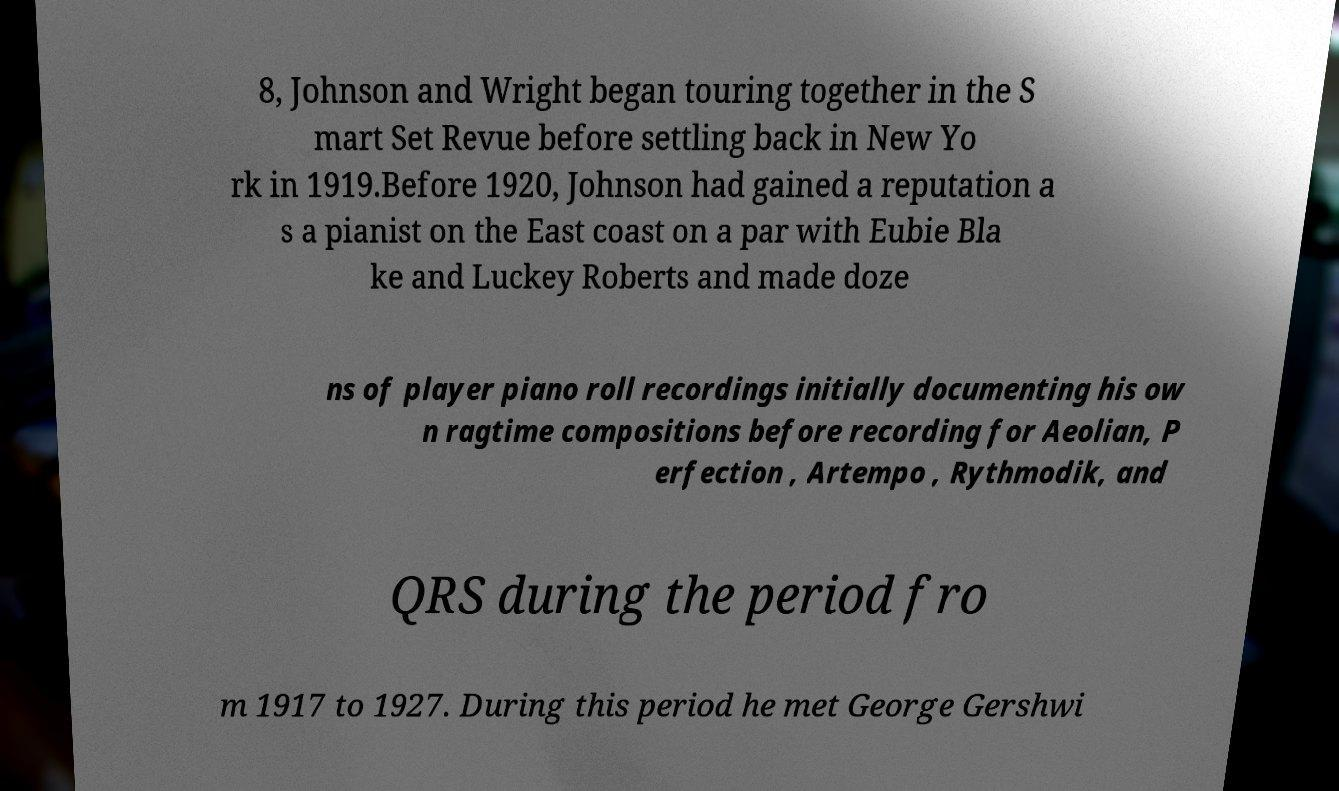Could you assist in decoding the text presented in this image and type it out clearly? 8, Johnson and Wright began touring together in the S mart Set Revue before settling back in New Yo rk in 1919.Before 1920, Johnson had gained a reputation a s a pianist on the East coast on a par with Eubie Bla ke and Luckey Roberts and made doze ns of player piano roll recordings initially documenting his ow n ragtime compositions before recording for Aeolian, P erfection , Artempo , Rythmodik, and QRS during the period fro m 1917 to 1927. During this period he met George Gershwi 